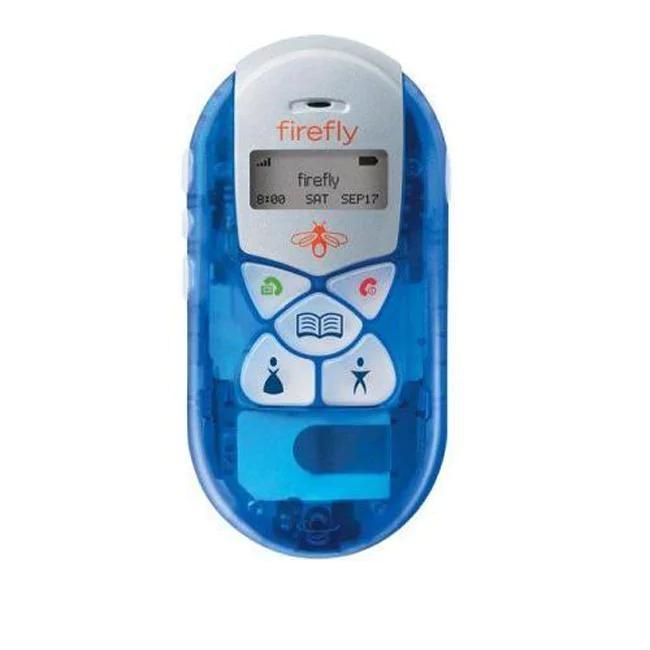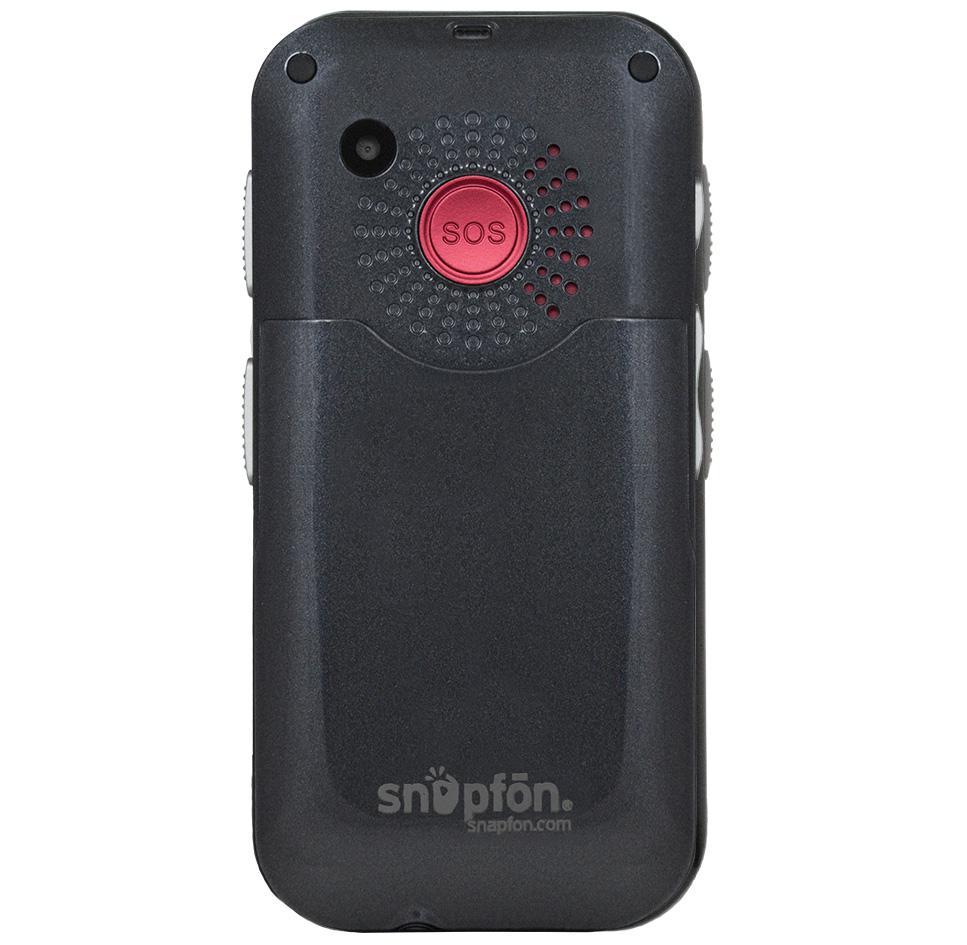The first image is the image on the left, the second image is the image on the right. Considering the images on both sides, is "There is a colorful remote control with non-grid buttons in one image, and a black piece of electronics in the other." valid? Answer yes or no. Yes. The first image is the image on the left, the second image is the image on the right. For the images shown, is this caption "There are two phones and one of them is ovalish." true? Answer yes or no. Yes. 